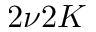Convert formula to latex. <formula><loc_0><loc_0><loc_500><loc_500>2 \nu 2 K</formula> 